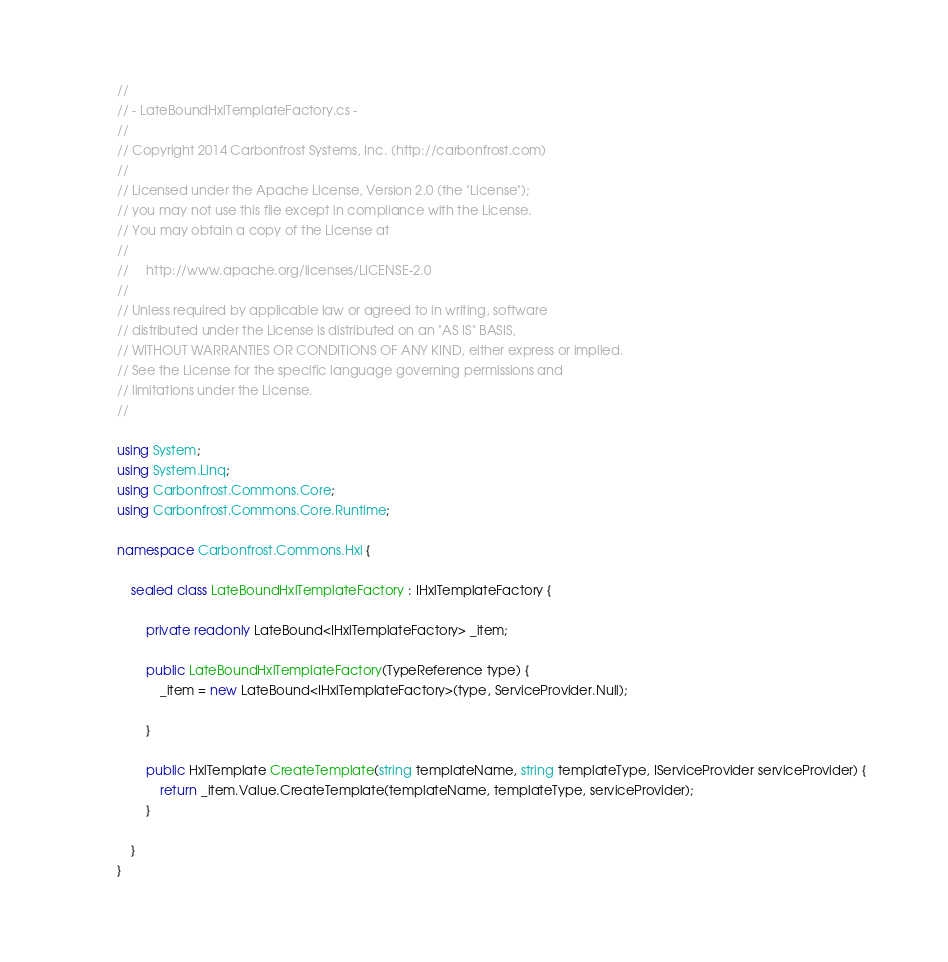Convert code to text. <code><loc_0><loc_0><loc_500><loc_500><_C#_>//
// - LateBoundHxlTemplateFactory.cs -
//
// Copyright 2014 Carbonfrost Systems, Inc. (http://carbonfrost.com)
//
// Licensed under the Apache License, Version 2.0 (the "License");
// you may not use this file except in compliance with the License.
// You may obtain a copy of the License at
//
//     http://www.apache.org/licenses/LICENSE-2.0
//
// Unless required by applicable law or agreed to in writing, software
// distributed under the License is distributed on an "AS IS" BASIS,
// WITHOUT WARRANTIES OR CONDITIONS OF ANY KIND, either express or implied.
// See the License for the specific language governing permissions and
// limitations under the License.
//

using System;
using System.Linq;
using Carbonfrost.Commons.Core;
using Carbonfrost.Commons.Core.Runtime;

namespace Carbonfrost.Commons.Hxl {

    sealed class LateBoundHxlTemplateFactory : IHxlTemplateFactory {

        private readonly LateBound<IHxlTemplateFactory> _item;

        public LateBoundHxlTemplateFactory(TypeReference type) {
            _item = new LateBound<IHxlTemplateFactory>(type, ServiceProvider.Null);

        }

        public HxlTemplate CreateTemplate(string templateName, string templateType, IServiceProvider serviceProvider) {
            return _item.Value.CreateTemplate(templateName, templateType, serviceProvider);
        }

    }
}

</code> 